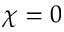Convert formula to latex. <formula><loc_0><loc_0><loc_500><loc_500>\chi = 0</formula> 